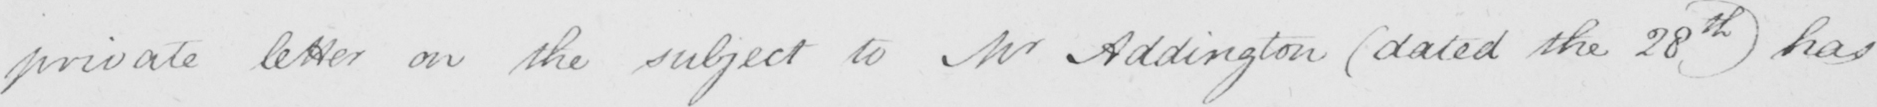Can you read and transcribe this handwriting? private letter on the subject to Mr Addington  ( dated the 28th )  has 